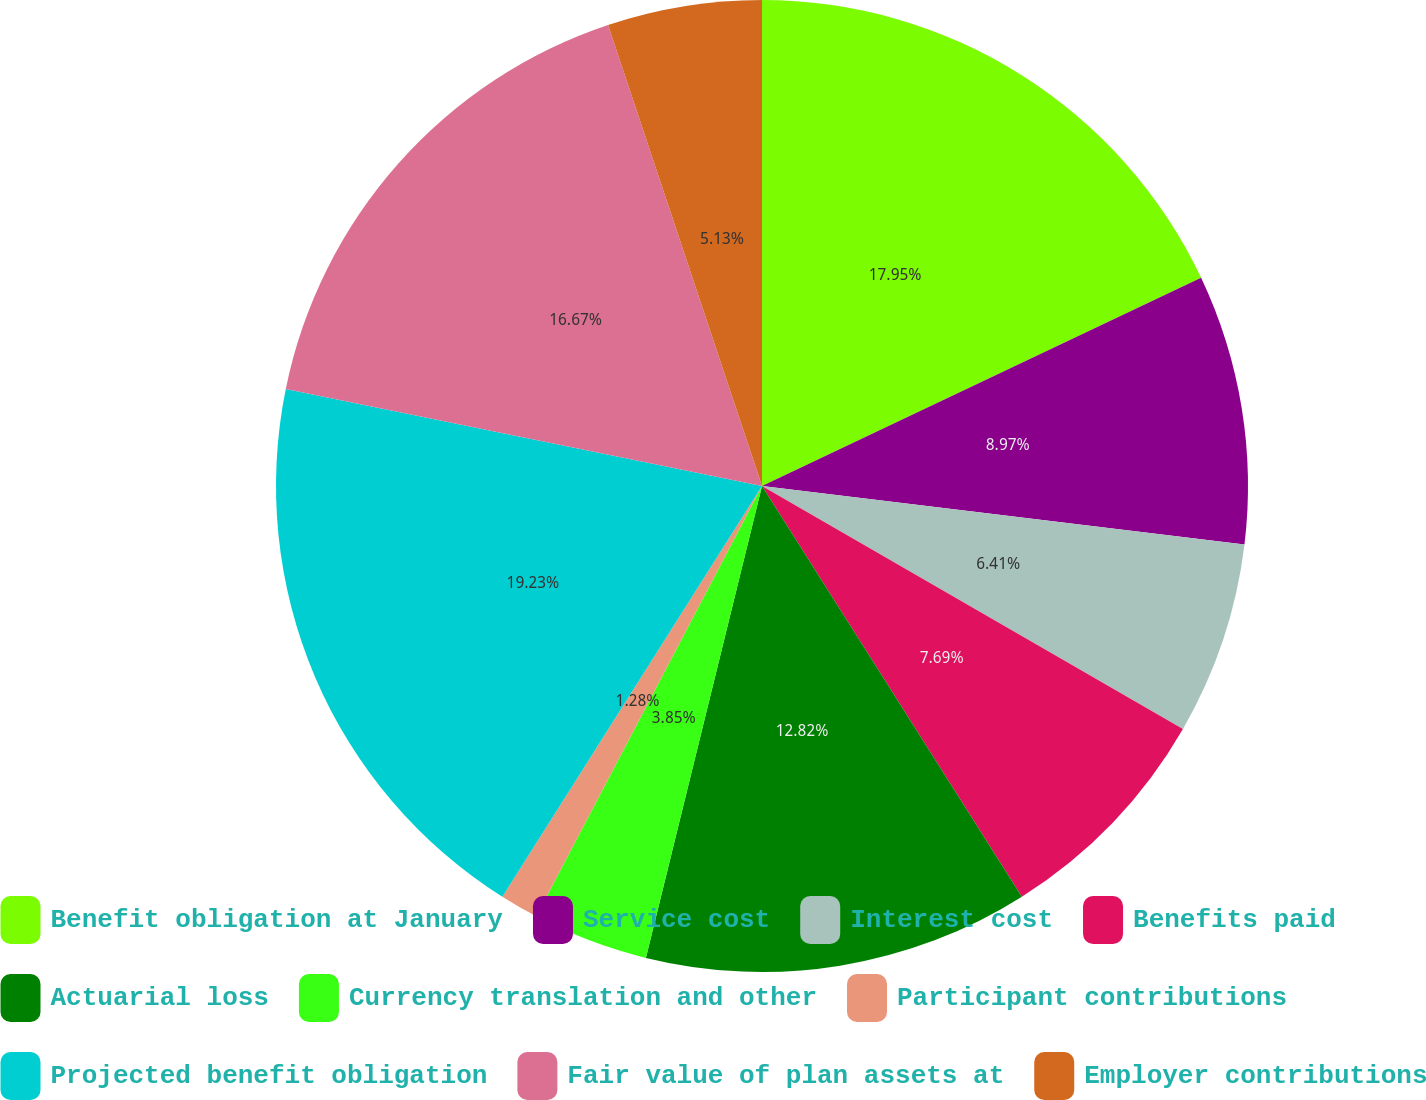<chart> <loc_0><loc_0><loc_500><loc_500><pie_chart><fcel>Benefit obligation at January<fcel>Service cost<fcel>Interest cost<fcel>Benefits paid<fcel>Actuarial loss<fcel>Currency translation and other<fcel>Participant contributions<fcel>Projected benefit obligation<fcel>Fair value of plan assets at<fcel>Employer contributions<nl><fcel>17.95%<fcel>8.97%<fcel>6.41%<fcel>7.69%<fcel>12.82%<fcel>3.85%<fcel>1.28%<fcel>19.23%<fcel>16.67%<fcel>5.13%<nl></chart> 